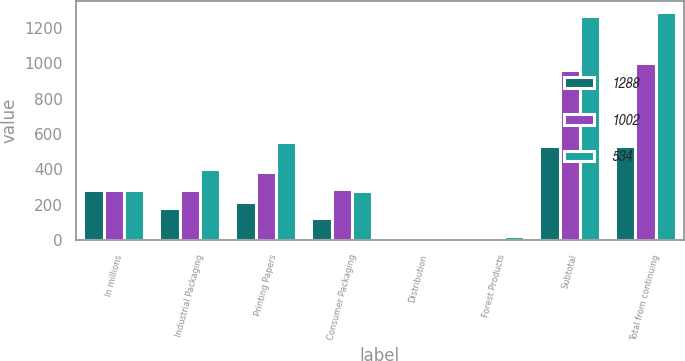Convert chart to OTSL. <chart><loc_0><loc_0><loc_500><loc_500><stacked_bar_chart><ecel><fcel>In millions<fcel>Industrial Packaging<fcel>Printing Papers<fcel>Consumer Packaging<fcel>Distribution<fcel>Forest Products<fcel>Subtotal<fcel>Total from continuing<nl><fcel>1288<fcel>282<fcel>183<fcel>218<fcel>126<fcel>6<fcel>1<fcel>534<fcel>534<nl><fcel>1002<fcel>282<fcel>282<fcel>383<fcel>287<fcel>9<fcel>2<fcel>963<fcel>1002<nl><fcel>534<fcel>282<fcel>405<fcel>556<fcel>276<fcel>6<fcel>22<fcel>1265<fcel>1288<nl></chart> 